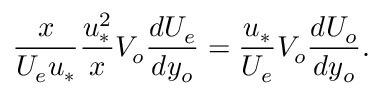Convert formula to latex. <formula><loc_0><loc_0><loc_500><loc_500>\frac { x } { U _ { e } u _ { * } } \frac { u _ { * } ^ { 2 } } { x } V _ { o } \frac { d U _ { e } } { d y _ { o } } = \frac { u _ { * } } { U _ { e } } V _ { o } \frac { d U _ { o } } { d y _ { o } } .</formula> 